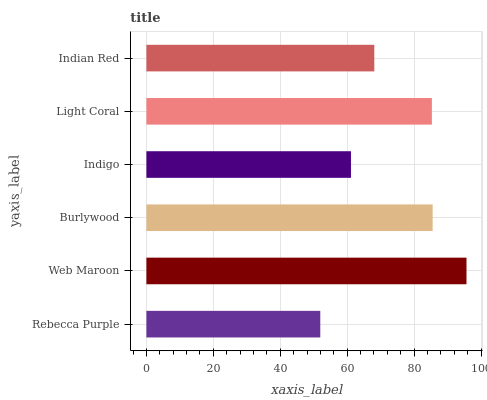Is Rebecca Purple the minimum?
Answer yes or no. Yes. Is Web Maroon the maximum?
Answer yes or no. Yes. Is Burlywood the minimum?
Answer yes or no. No. Is Burlywood the maximum?
Answer yes or no. No. Is Web Maroon greater than Burlywood?
Answer yes or no. Yes. Is Burlywood less than Web Maroon?
Answer yes or no. Yes. Is Burlywood greater than Web Maroon?
Answer yes or no. No. Is Web Maroon less than Burlywood?
Answer yes or no. No. Is Light Coral the high median?
Answer yes or no. Yes. Is Indian Red the low median?
Answer yes or no. Yes. Is Indian Red the high median?
Answer yes or no. No. Is Burlywood the low median?
Answer yes or no. No. 